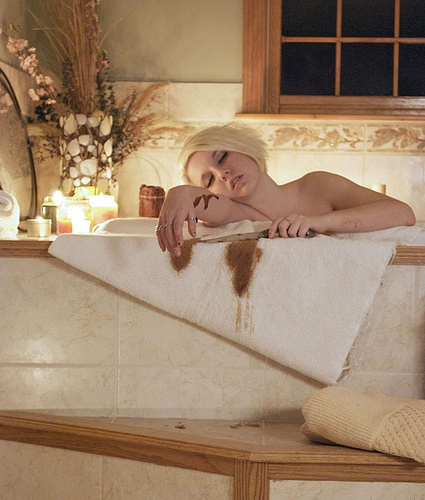Describe the objects in this image and their specific colors. I can see people in gray, tan, and brown tones, potted plant in gray, maroon, and ivory tones, vase in gray, ivory, khaki, and tan tones, and knife in gray, brown, and maroon tones in this image. 